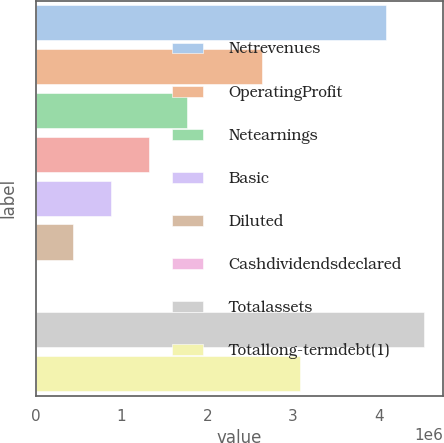<chart> <loc_0><loc_0><loc_500><loc_500><bar_chart><fcel>Netrevenues<fcel>OperatingProfit<fcel>Netearnings<fcel>Unnamed: 3<fcel>Basic<fcel>Diluted<fcel>Cashdividendsdeclared<fcel>Totalassets<fcel>Totallong-termdebt(1)<nl><fcel>4.08216e+06<fcel>2.63593e+06<fcel>1.75729e+06<fcel>1.31797e+06<fcel>878645<fcel>439324<fcel>1.6<fcel>4.52148e+06<fcel>3.07526e+06<nl></chart> 